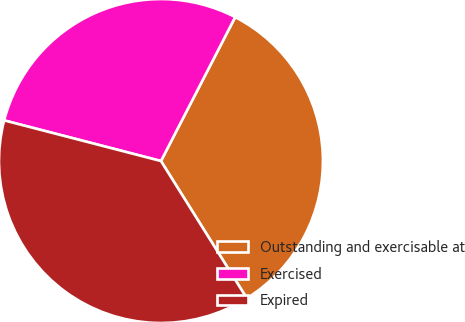<chart> <loc_0><loc_0><loc_500><loc_500><pie_chart><fcel>Outstanding and exercisable at<fcel>Exercised<fcel>Expired<nl><fcel>33.52%<fcel>28.54%<fcel>37.93%<nl></chart> 